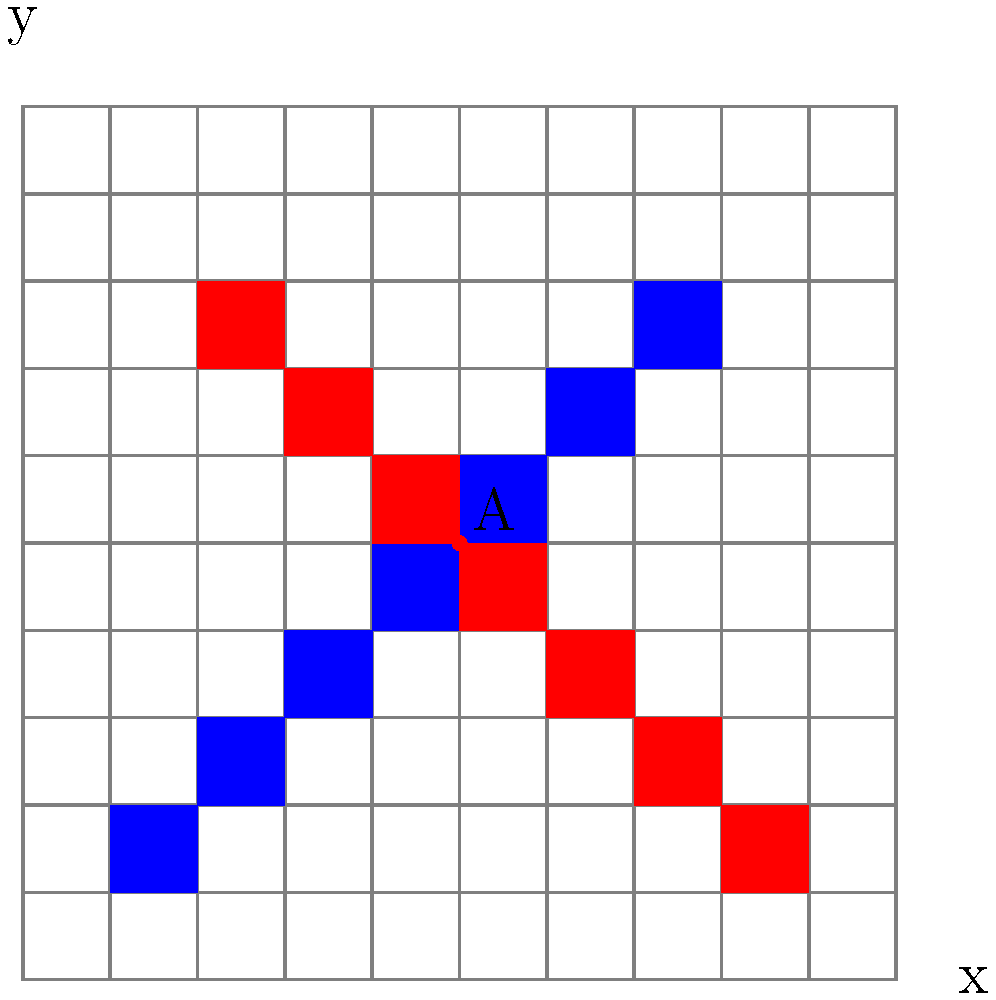In a retro-style 2D game environment, two pixelated diagonal lines are drawn on a 10x10 grid. The blue line can be approximated by the equation $y = x$, while the red line can be approximated by $y = -x + 9$. Determine the coordinates of the intersection point A of these two pixelated lines, considering that the lines are composed of discrete pixels. To solve this problem, we'll follow these steps:

1) First, we need to understand that in a pixelated environment, the intersection won't be as precise as in continuous space. We're looking for the pixel where the two lines overlap.

2) The equations of the lines are:
   Blue line: $y = x$
   Red line: $y = -x + 9$

3) In continuous space, we would solve these equations simultaneously:
   $x = -x + 9$
   $2x = 9$
   $x = 4.5$
   $y = 4.5$

4) However, in our pixelated grid, we need to round these values to the nearest integer.

5) Looking at the grid, we can see that the lines intersect at the pixel with coordinates (5,5).

6) We can verify this:
   For the blue line: When $x = 5$, $y = 5$
   For the red line: When $x = 5$, $y = -5 + 9 = 4$, which rounds up to 5 in our pixelated representation.

7) Therefore, the intersection point A of these two pixelated lines is at the coordinates (5,5).

This solution combines the mathematical approach of solving linear equations with the practical considerations of working with discrete pixels, much like in retro video game graphics.
Answer: (5,5) 